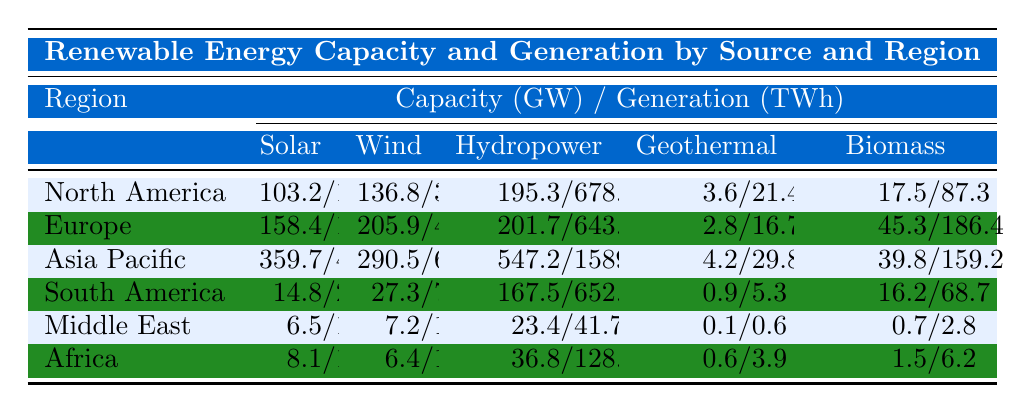What is the solar capacity in Asia Pacific? The table shows that the solar capacity in Asia Pacific is listed as 359.7 GW.
Answer: 359.7 GW Which region has the highest wind generation? By checking the wind generation values, Asia Pacific has the highest wind generation at 632.7 TWh.
Answer: Asia Pacific What is the total hydropower capacity across all regions? To find the total hydropower capacity, sum the values: 195.3 + 201.7 + 547.2 + 167.5 + 23.4 + 36.8 = 1171.9 GW.
Answer: 1171.9 GW Is the biomass generation in Europe greater than in Africa? Comparing the biomass generation values, Europe has 186.4 TWh and Africa has 6.2 TWh, so the statement is true.
Answer: Yes What is the difference in solar generation between North America and South America? The difference is calculated as North America's solar generation (142.7 TWh) minus South America's solar generation (23.6 TWh), which equals 119.1 TWh.
Answer: 119.1 TWh Which region has the least hydropower generation and what is the value? The table indicates that the Middle East has the least hydropower generation at 41.7 TWh.
Answer: Middle East, 41.7 TWh What is the average geothermal capacity across all regions? To calculate the average, sum the geothermal capacities: 3.6 + 2.8 + 4.2 + 0.9 + 0.1 + 0.6 = 12.2 GW, then divide by 6, resulting in an average of 2.03 GW.
Answer: 2.03 GW Is wind capacity in Europe higher than solar capacity in North America? The wind capacity in Europe is 205.9 GW and solar capacity in North America is 103.2 GW, confirming that the statement is true.
Answer: Yes What is the combined capacity of solar and wind energy in Africa? The combined capacity is 8.1 GW (solar) + 6.4 GW (wind) = 14.5 GW.
Answer: 14.5 GW If Asia Pacific increased its geothermal capacity by 1 GW, what would be its new total? The current geothermal capacity in Asia Pacific is 4.2 GW, increased by 1 GW would make it 5.2 GW.
Answer: 5.2 GW 